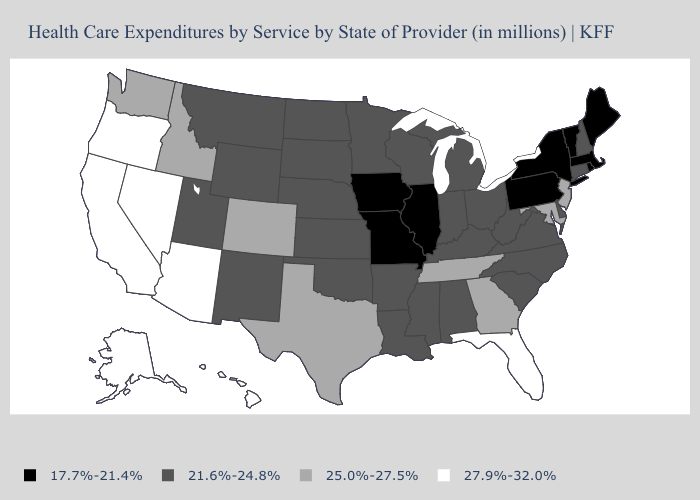What is the value of Alaska?
Short answer required. 27.9%-32.0%. What is the lowest value in the South?
Write a very short answer. 21.6%-24.8%. Does Maryland have a lower value than Washington?
Answer briefly. No. Among the states that border Nebraska , does Colorado have the highest value?
Answer briefly. Yes. Which states hav the highest value in the MidWest?
Write a very short answer. Indiana, Kansas, Michigan, Minnesota, Nebraska, North Dakota, Ohio, South Dakota, Wisconsin. What is the value of Ohio?
Write a very short answer. 21.6%-24.8%. Which states hav the highest value in the MidWest?
Write a very short answer. Indiana, Kansas, Michigan, Minnesota, Nebraska, North Dakota, Ohio, South Dakota, Wisconsin. Does Indiana have the highest value in the USA?
Write a very short answer. No. Among the states that border Massachusetts , which have the lowest value?
Be succinct. New York, Rhode Island, Vermont. Does the map have missing data?
Be succinct. No. Does the map have missing data?
Short answer required. No. What is the value of Idaho?
Short answer required. 25.0%-27.5%. What is the lowest value in the USA?
Keep it brief. 17.7%-21.4%. Among the states that border Kansas , does Missouri have the highest value?
Keep it brief. No. Does Texas have the lowest value in the USA?
Answer briefly. No. 